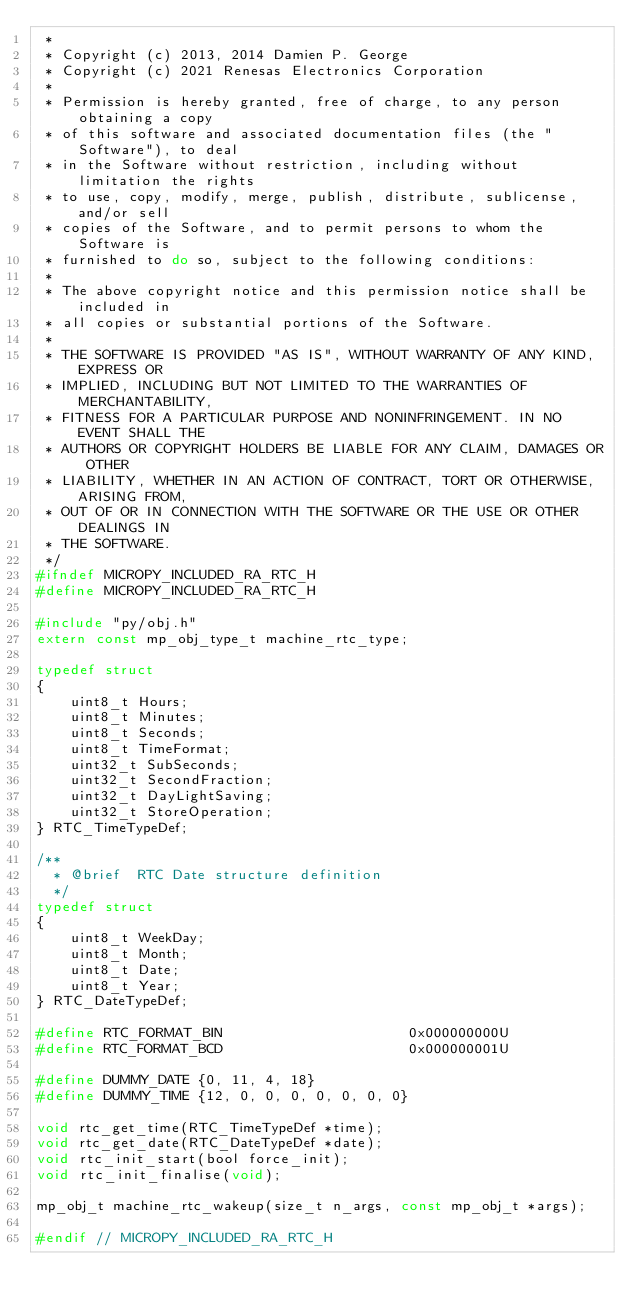Convert code to text. <code><loc_0><loc_0><loc_500><loc_500><_C_> *
 * Copyright (c) 2013, 2014 Damien P. George
 * Copyright (c) 2021 Renesas Electronics Corporation
 *
 * Permission is hereby granted, free of charge, to any person obtaining a copy
 * of this software and associated documentation files (the "Software"), to deal
 * in the Software without restriction, including without limitation the rights
 * to use, copy, modify, merge, publish, distribute, sublicense, and/or sell
 * copies of the Software, and to permit persons to whom the Software is
 * furnished to do so, subject to the following conditions:
 *
 * The above copyright notice and this permission notice shall be included in
 * all copies or substantial portions of the Software.
 *
 * THE SOFTWARE IS PROVIDED "AS IS", WITHOUT WARRANTY OF ANY KIND, EXPRESS OR
 * IMPLIED, INCLUDING BUT NOT LIMITED TO THE WARRANTIES OF MERCHANTABILITY,
 * FITNESS FOR A PARTICULAR PURPOSE AND NONINFRINGEMENT. IN NO EVENT SHALL THE
 * AUTHORS OR COPYRIGHT HOLDERS BE LIABLE FOR ANY CLAIM, DAMAGES OR OTHER
 * LIABILITY, WHETHER IN AN ACTION OF CONTRACT, TORT OR OTHERWISE, ARISING FROM,
 * OUT OF OR IN CONNECTION WITH THE SOFTWARE OR THE USE OR OTHER DEALINGS IN
 * THE SOFTWARE.
 */
#ifndef MICROPY_INCLUDED_RA_RTC_H
#define MICROPY_INCLUDED_RA_RTC_H

#include "py/obj.h"
extern const mp_obj_type_t machine_rtc_type;

typedef struct
{
    uint8_t Hours;
    uint8_t Minutes;
    uint8_t Seconds;
    uint8_t TimeFormat;
    uint32_t SubSeconds;
    uint32_t SecondFraction;
    uint32_t DayLightSaving;
    uint32_t StoreOperation;
} RTC_TimeTypeDef;

/**
  * @brief  RTC Date structure definition
  */
typedef struct
{
    uint8_t WeekDay;
    uint8_t Month;
    uint8_t Date;
    uint8_t Year;
} RTC_DateTypeDef;

#define RTC_FORMAT_BIN                      0x000000000U
#define RTC_FORMAT_BCD                      0x000000001U

#define DUMMY_DATE {0, 11, 4, 18}
#define DUMMY_TIME {12, 0, 0, 0, 0, 0, 0, 0}

void rtc_get_time(RTC_TimeTypeDef *time);
void rtc_get_date(RTC_DateTypeDef *date);
void rtc_init_start(bool force_init);
void rtc_init_finalise(void);

mp_obj_t machine_rtc_wakeup(size_t n_args, const mp_obj_t *args);

#endif // MICROPY_INCLUDED_RA_RTC_H
</code> 